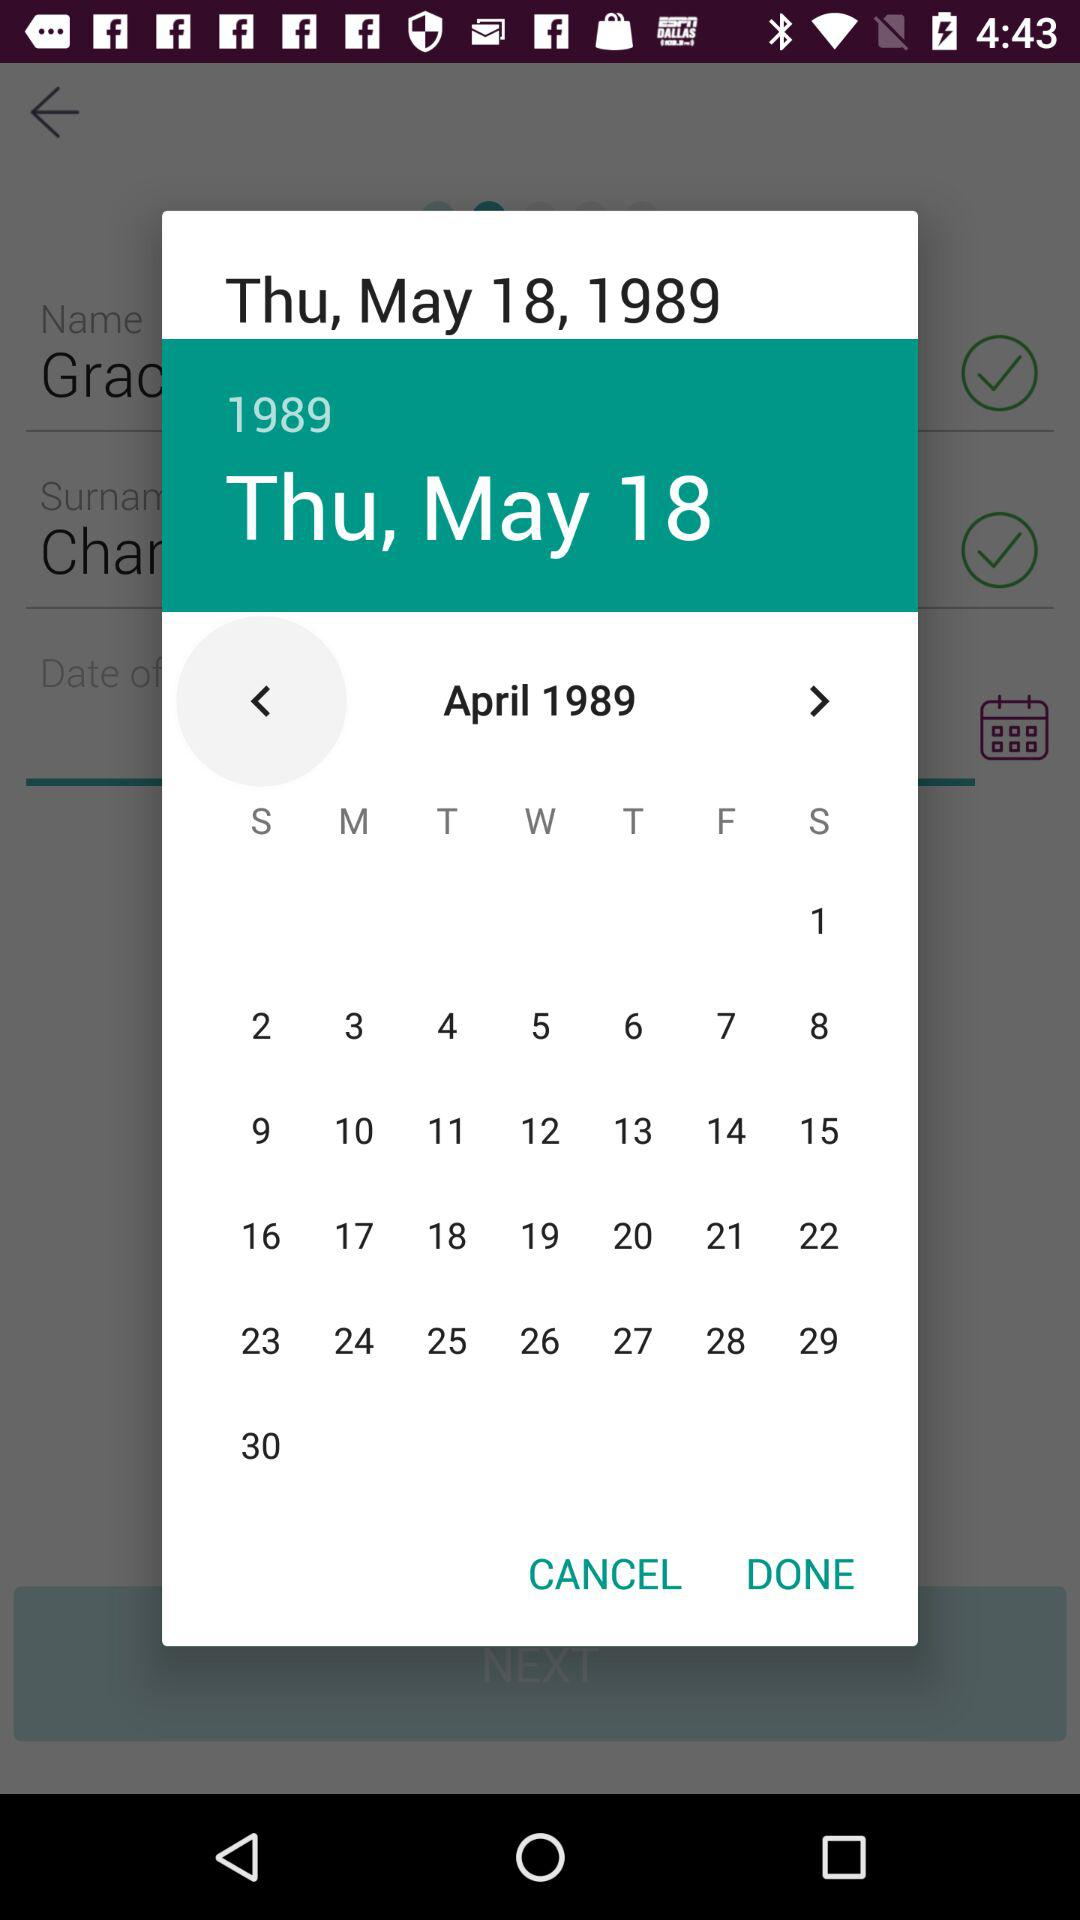Which date is selected on the calendar? The selected date is Thursday, May 18, 1989. 